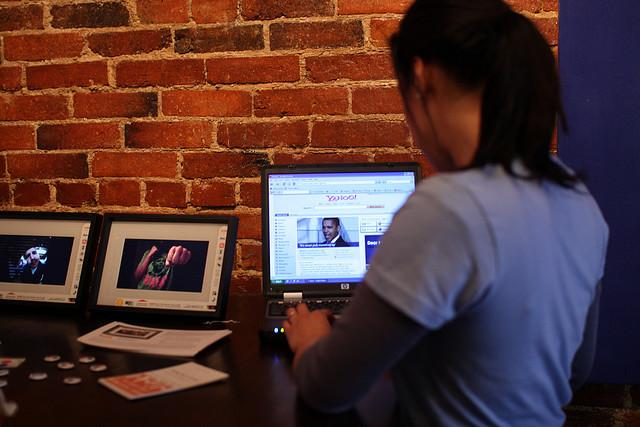In what year did the website on her screen become a company? Please explain your reasoning. 1994. This was the period of evolution in most countries. 